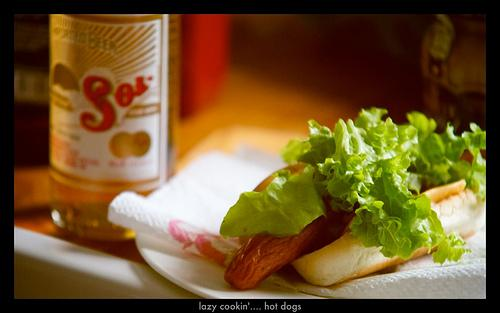Question: what is on the hot dog?
Choices:
A. Lettuce.
B. Ketchup.
C. Mustard.
D. Onions.
Answer with the letter. Answer: A Question: what is in the bun?
Choices:
A. A hamburger.
B. A hot dog.
C. Chicken.
D. Sausage.
Answer with the letter. Answer: B Question: who is in the photo?
Choices:
A. Nobody.
B. A man.
C. A lady.
D. A family.
Answer with the letter. Answer: A Question: what color is the napkin?
Choices:
A. Gray.
B. Red.
C. White.
D. Blue.
Answer with the letter. Answer: C 